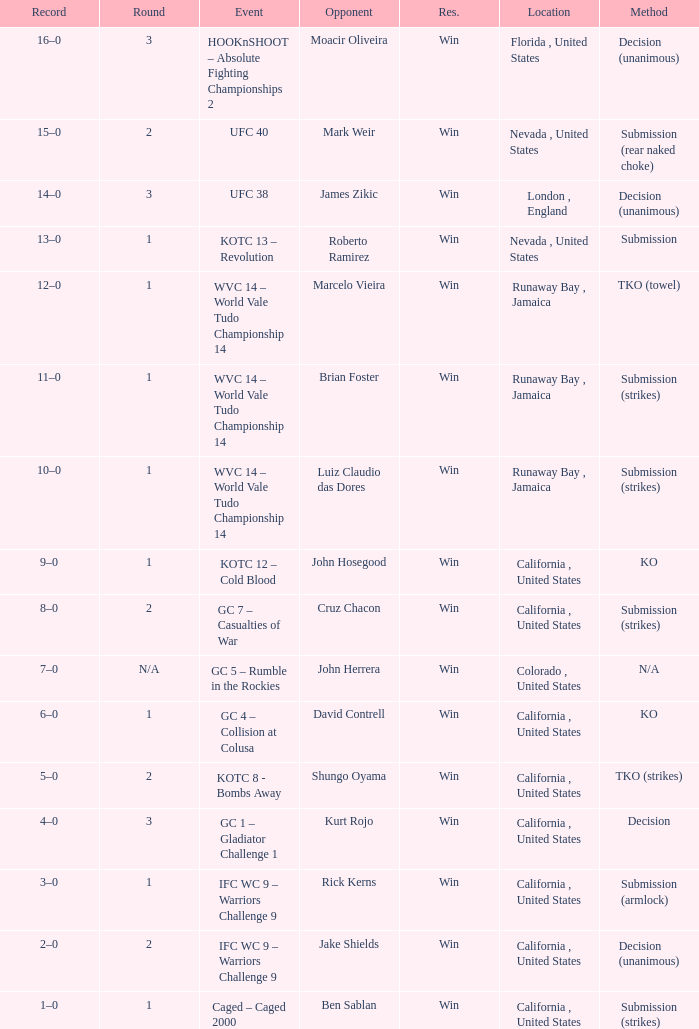Where was the fight located that lasted 1 round against luiz claudio das dores? Runaway Bay , Jamaica. 